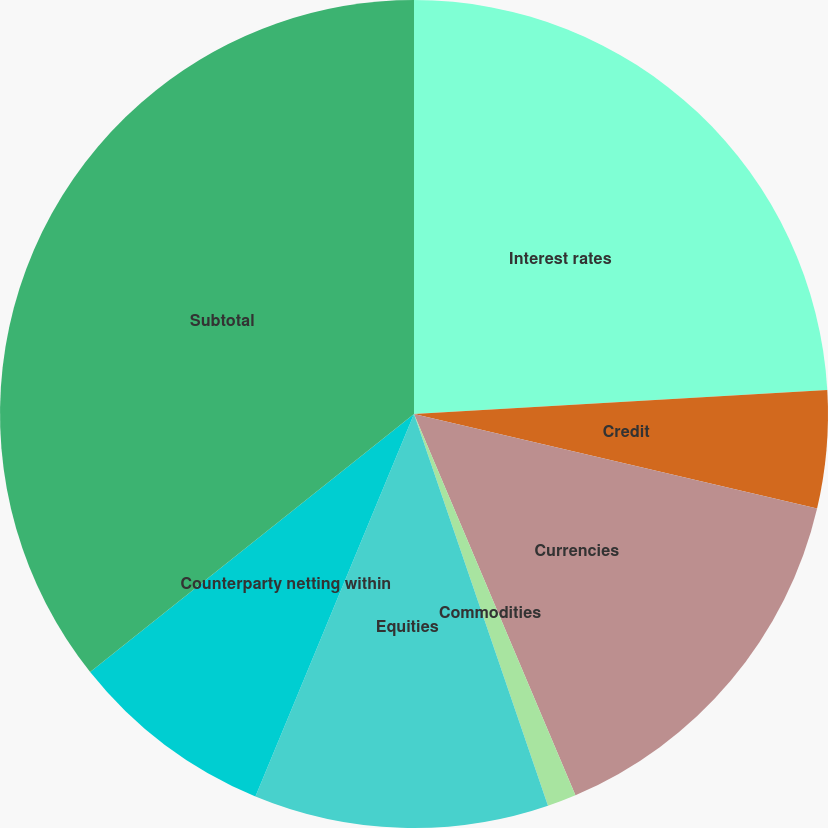<chart> <loc_0><loc_0><loc_500><loc_500><pie_chart><fcel>Interest rates<fcel>Credit<fcel>Currencies<fcel>Commodities<fcel>Equities<fcel>Counterparty netting within<fcel>Subtotal<nl><fcel>24.07%<fcel>4.59%<fcel>14.96%<fcel>1.13%<fcel>11.5%<fcel>8.04%<fcel>35.7%<nl></chart> 